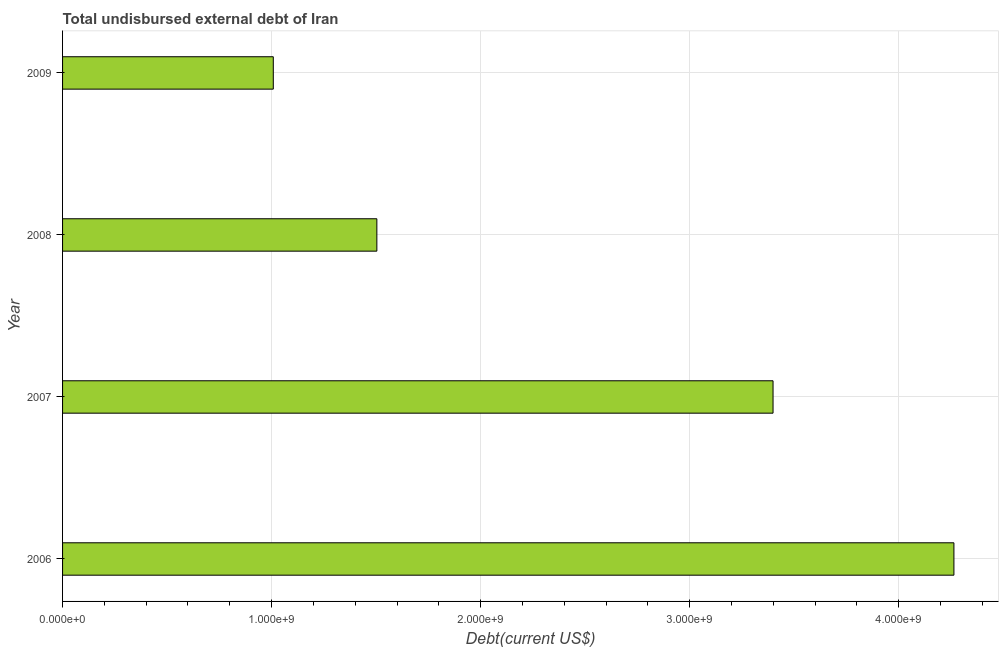Does the graph contain grids?
Make the answer very short. Yes. What is the title of the graph?
Your response must be concise. Total undisbursed external debt of Iran. What is the label or title of the X-axis?
Offer a very short reply. Debt(current US$). What is the total debt in 2008?
Give a very brief answer. 1.50e+09. Across all years, what is the maximum total debt?
Provide a short and direct response. 4.26e+09. Across all years, what is the minimum total debt?
Your response must be concise. 1.01e+09. In which year was the total debt maximum?
Your answer should be compact. 2006. In which year was the total debt minimum?
Ensure brevity in your answer.  2009. What is the sum of the total debt?
Give a very brief answer. 1.02e+1. What is the difference between the total debt in 2008 and 2009?
Provide a succinct answer. 4.95e+08. What is the average total debt per year?
Give a very brief answer. 2.54e+09. What is the median total debt?
Offer a terse response. 2.45e+09. What is the ratio of the total debt in 2006 to that in 2009?
Provide a succinct answer. 4.23. What is the difference between the highest and the second highest total debt?
Give a very brief answer. 8.65e+08. Is the sum of the total debt in 2006 and 2009 greater than the maximum total debt across all years?
Offer a very short reply. Yes. What is the difference between the highest and the lowest total debt?
Provide a succinct answer. 3.26e+09. In how many years, is the total debt greater than the average total debt taken over all years?
Give a very brief answer. 2. How many bars are there?
Your response must be concise. 4. How many years are there in the graph?
Offer a very short reply. 4. What is the Debt(current US$) of 2006?
Provide a short and direct response. 4.26e+09. What is the Debt(current US$) in 2007?
Keep it short and to the point. 3.40e+09. What is the Debt(current US$) in 2008?
Provide a short and direct response. 1.50e+09. What is the Debt(current US$) of 2009?
Your answer should be compact. 1.01e+09. What is the difference between the Debt(current US$) in 2006 and 2007?
Make the answer very short. 8.65e+08. What is the difference between the Debt(current US$) in 2006 and 2008?
Offer a terse response. 2.76e+09. What is the difference between the Debt(current US$) in 2006 and 2009?
Give a very brief answer. 3.26e+09. What is the difference between the Debt(current US$) in 2007 and 2008?
Your answer should be very brief. 1.90e+09. What is the difference between the Debt(current US$) in 2007 and 2009?
Provide a short and direct response. 2.39e+09. What is the difference between the Debt(current US$) in 2008 and 2009?
Your answer should be compact. 4.95e+08. What is the ratio of the Debt(current US$) in 2006 to that in 2007?
Offer a very short reply. 1.25. What is the ratio of the Debt(current US$) in 2006 to that in 2008?
Your response must be concise. 2.84. What is the ratio of the Debt(current US$) in 2006 to that in 2009?
Provide a short and direct response. 4.23. What is the ratio of the Debt(current US$) in 2007 to that in 2008?
Make the answer very short. 2.26. What is the ratio of the Debt(current US$) in 2007 to that in 2009?
Your answer should be compact. 3.37. What is the ratio of the Debt(current US$) in 2008 to that in 2009?
Offer a terse response. 1.49. 